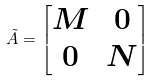<formula> <loc_0><loc_0><loc_500><loc_500>\tilde { A } = \begin{bmatrix} M & 0 \\ 0 & N \end{bmatrix}</formula> 